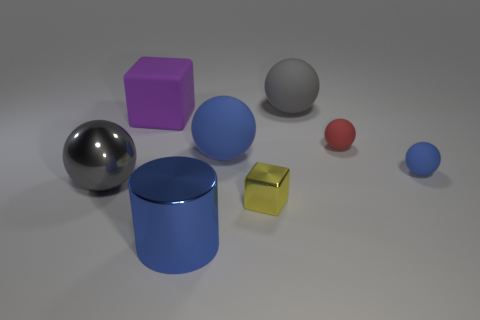Subtract all cyan balls. Subtract all cyan blocks. How many balls are left? 5 Add 2 tiny red rubber spheres. How many objects exist? 10 Subtract all cylinders. How many objects are left? 7 Subtract all tiny cyan cylinders. Subtract all shiny things. How many objects are left? 5 Add 7 tiny blue matte balls. How many tiny blue matte balls are left? 8 Add 7 blue shiny objects. How many blue shiny objects exist? 8 Subtract 1 blue spheres. How many objects are left? 7 